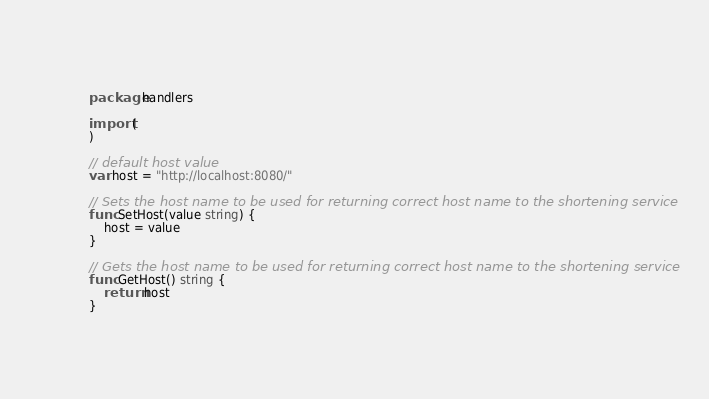Convert code to text. <code><loc_0><loc_0><loc_500><loc_500><_Go_>package handlers

import (
)

// default host value
var host = "http://localhost:8080/"

// Sets the host name to be used for returning correct host name to the shortening service
func SetHost(value string) {
	host = value
}

// Gets the host name to be used for returning correct host name to the shortening service
func GetHost() string {
	return host
}</code> 